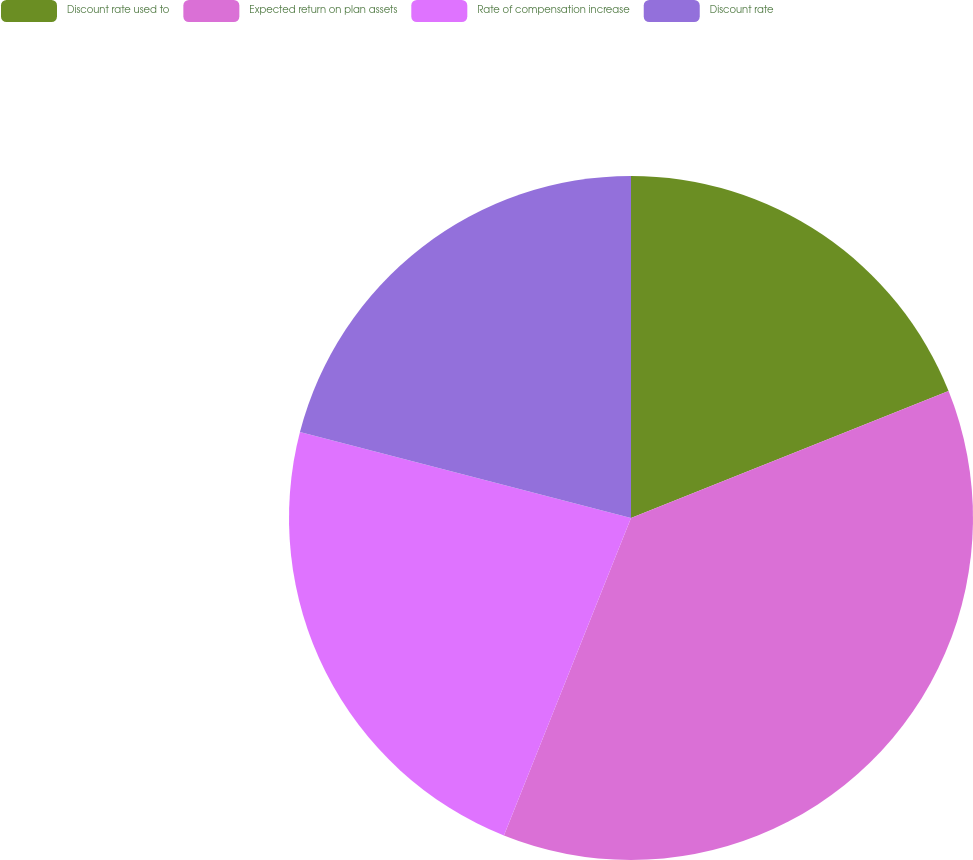Convert chart to OTSL. <chart><loc_0><loc_0><loc_500><loc_500><pie_chart><fcel>Discount rate used to<fcel>Expected return on plan assets<fcel>Rate of compensation increase<fcel>Discount rate<nl><fcel>18.95%<fcel>37.11%<fcel>22.98%<fcel>20.96%<nl></chart> 